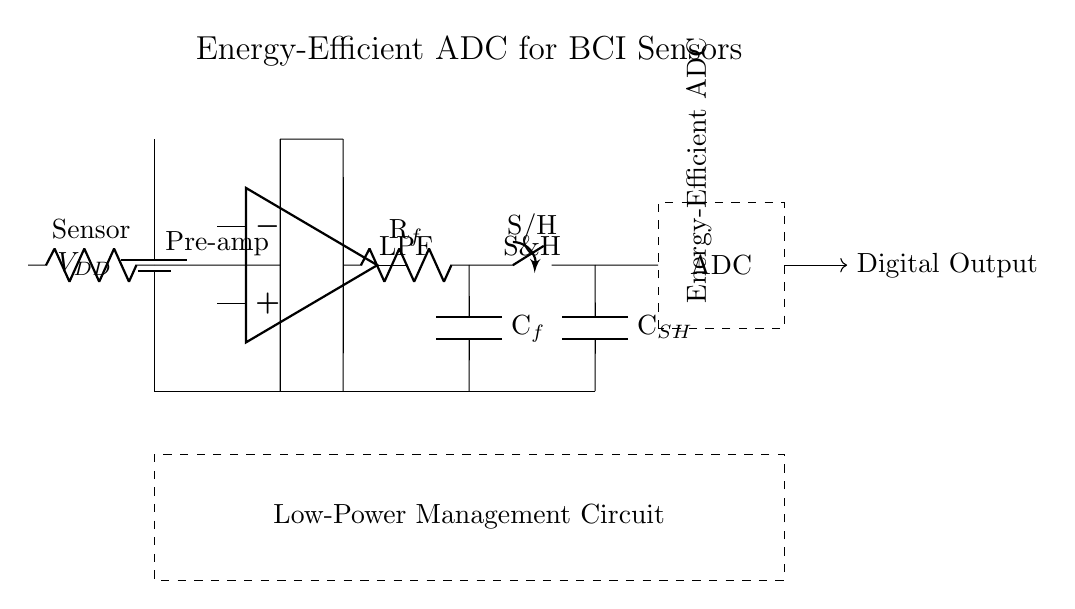What is the type of amplifier used in this circuit? The circuit diagram shows an operational amplifier, indicated by the op amp symbol. This is a key component used for signal amplification.
Answer: Operational amplifier What does the R in Rf represent? In the context of the circuit, Rf refers to a resistor that is part of a low-pass filter circuit, used for filtering out high-frequency noise from the sensor signal.
Answer: Resistor How many main functional blocks are present in this circuit? By analyzing the diagram, there are four main functional blocks: the pre-amplifier, low-pass filter, sample and hold circuit, and the ADC.
Answer: Four What is the purpose of the sample and hold circuit? The sample and hold circuit captures the voltage from the analog signal at a specific moment in time, allowing the ADC to process a stable input for conversion.
Answer: Capturing voltage What is the primary function of the ADC in this circuit? The ADC converts the analog signal from the sensor, after amplification and filtering, into a digital format suitable for processing or transmission.
Answer: Conversion What type of power management is indicated in this circuit? The circuit shows a low-power management circuit, which is essential for energy efficiency in devices that rely on battery-operated sensors.
Answer: Low-power management circuit What does the capacitor labeled Csh do in this circuit? The capacitor Csh in the sample and hold block is used to store charge and maintain the voltage level during the hold period while the ADC processes the information.
Answer: Store charge 